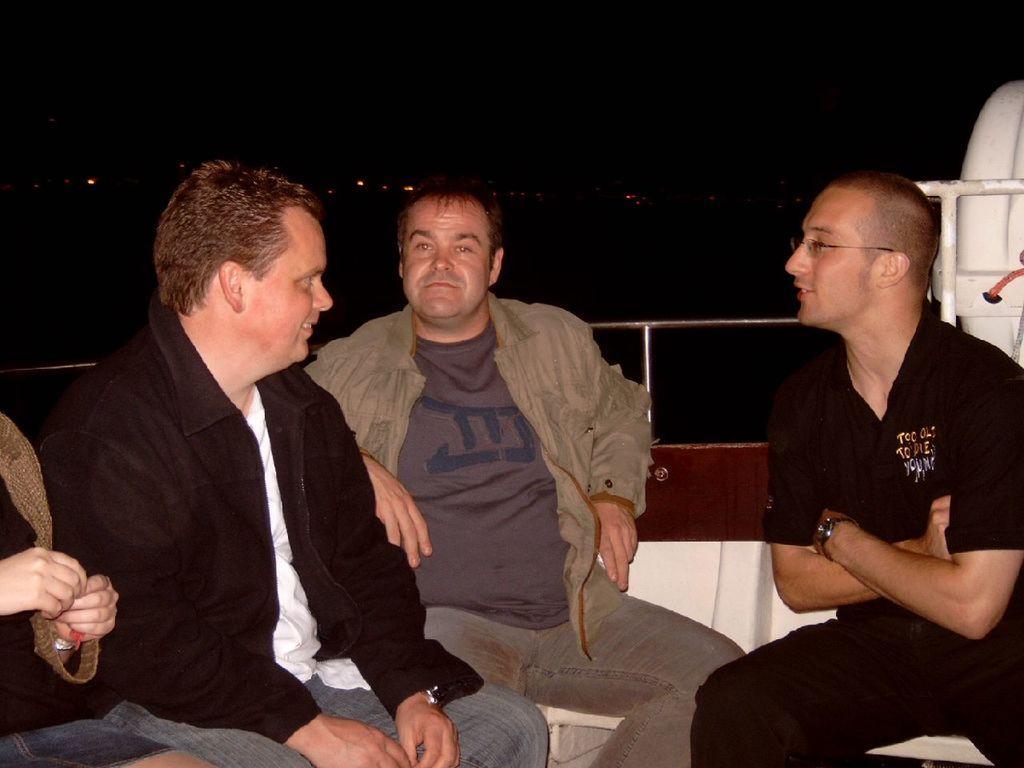How would you summarize this image in a sentence or two? Here I can see four persons sitting. It is looking like inside view of a boat. At the back of these people I can see the railing. It seems like they are discussing something. The background is in black color. 